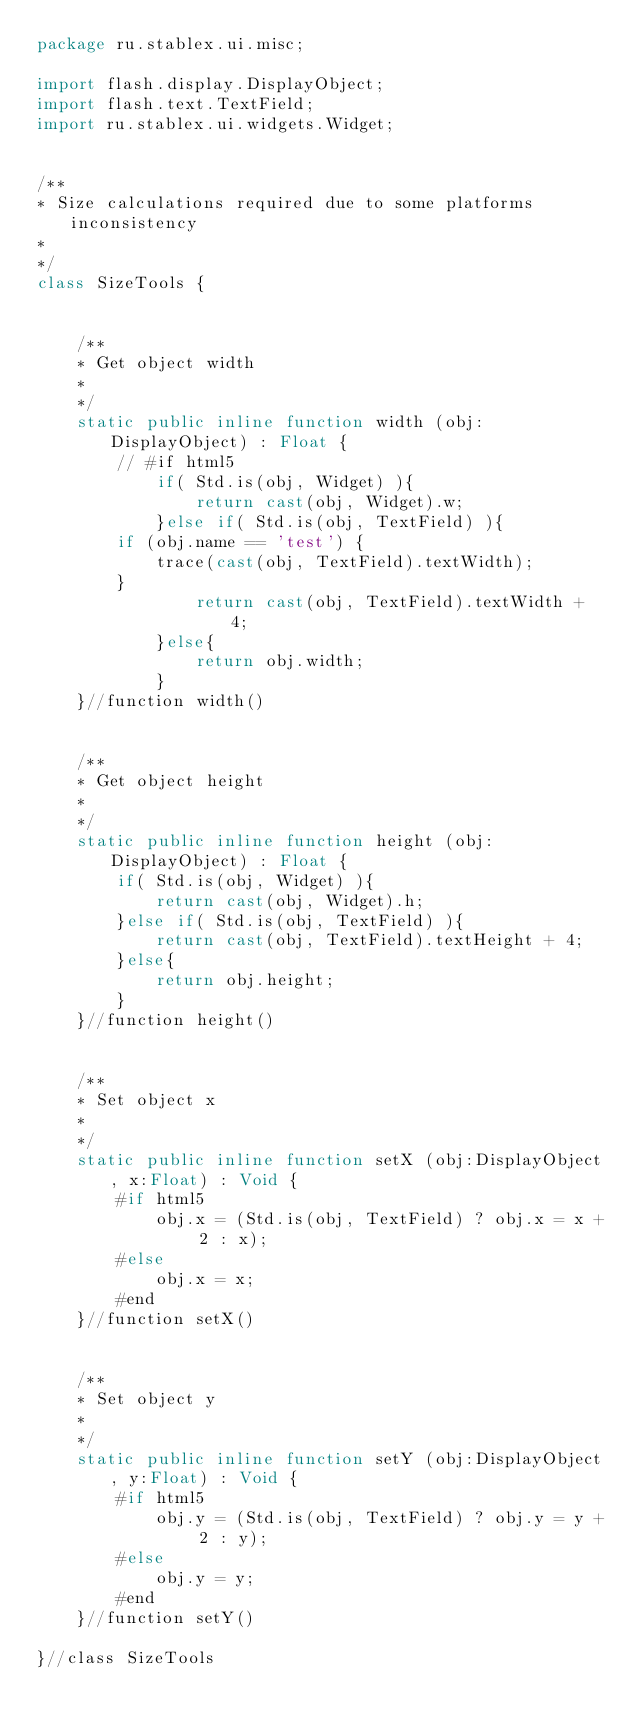Convert code to text. <code><loc_0><loc_0><loc_500><loc_500><_Haxe_>package ru.stablex.ui.misc;

import flash.display.DisplayObject;
import flash.text.TextField;
import ru.stablex.ui.widgets.Widget;


/**
* Size calculations required due to some platforms inconsistency
*
*/
class SizeTools {


    /**
    * Get object width
    *
    */
    static public inline function width (obj:DisplayObject) : Float {
        // #if html5
            if( Std.is(obj, Widget) ){
                return cast(obj, Widget).w;
            }else if( Std.is(obj, TextField) ){
        if (obj.name == 'test') {
            trace(cast(obj, TextField).textWidth);
        }
                return cast(obj, TextField).textWidth + 4;
            }else{
                return obj.width;
            }
    }//function width()


    /**
    * Get object height
    *
    */
    static public inline function height (obj:DisplayObject) : Float {
        if( Std.is(obj, Widget) ){
            return cast(obj, Widget).h;
        }else if( Std.is(obj, TextField) ){
            return cast(obj, TextField).textHeight + 4;
        }else{
            return obj.height;
        }
    }//function height()


    /**
    * Set object x
    *
    */
    static public inline function setX (obj:DisplayObject, x:Float) : Void {
        #if html5
            obj.x = (Std.is(obj, TextField) ? obj.x = x + 2 : x);
        #else
            obj.x = x;
        #end
    }//function setX()


    /**
    * Set object y
    *
    */
    static public inline function setY (obj:DisplayObject, y:Float) : Void {
        #if html5
            obj.y = (Std.is(obj, TextField) ? obj.y = y + 2 : y);
        #else
            obj.y = y;
        #end
    }//function setY()

}//class SizeTools</code> 